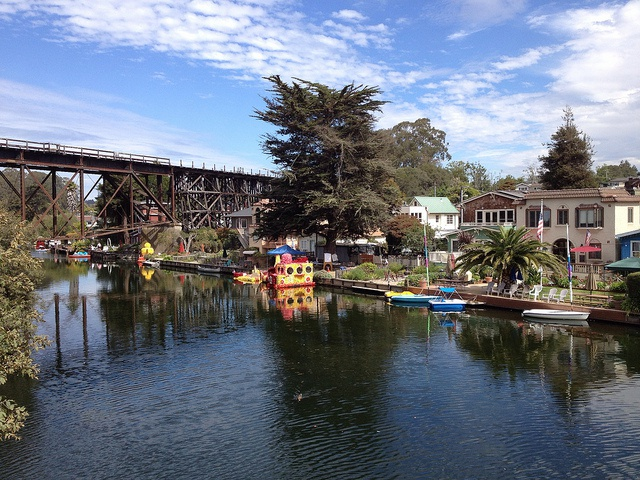Describe the objects in this image and their specific colors. I can see boat in lavender, black, maroon, and khaki tones, boat in lavender, black, navy, gray, and lightgray tones, boat in lavender, darkgray, white, gray, and black tones, boat in lavender, white, teal, yellow, and black tones, and umbrella in lavender, black, gray, and darkgray tones in this image. 